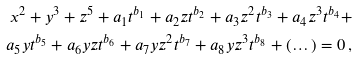Convert formula to latex. <formula><loc_0><loc_0><loc_500><loc_500>x ^ { 2 } + y ^ { 3 } + z ^ { 5 } + a _ { 1 } t ^ { b _ { 1 } } + a _ { 2 } z t ^ { b _ { 2 } } + a _ { 3 } z ^ { 2 } t ^ { b _ { 3 } } + a _ { 4 } z ^ { 3 } t ^ { b _ { 4 } } + \\ a _ { 5 } y t ^ { b _ { 5 } } + a _ { 6 } y z t ^ { b _ { 6 } } + a _ { 7 } y z ^ { 2 } t ^ { b _ { 7 } } + a _ { 8 } y z ^ { 3 } t ^ { b _ { 8 } } + ( \dots ) = 0 \, ,</formula> 